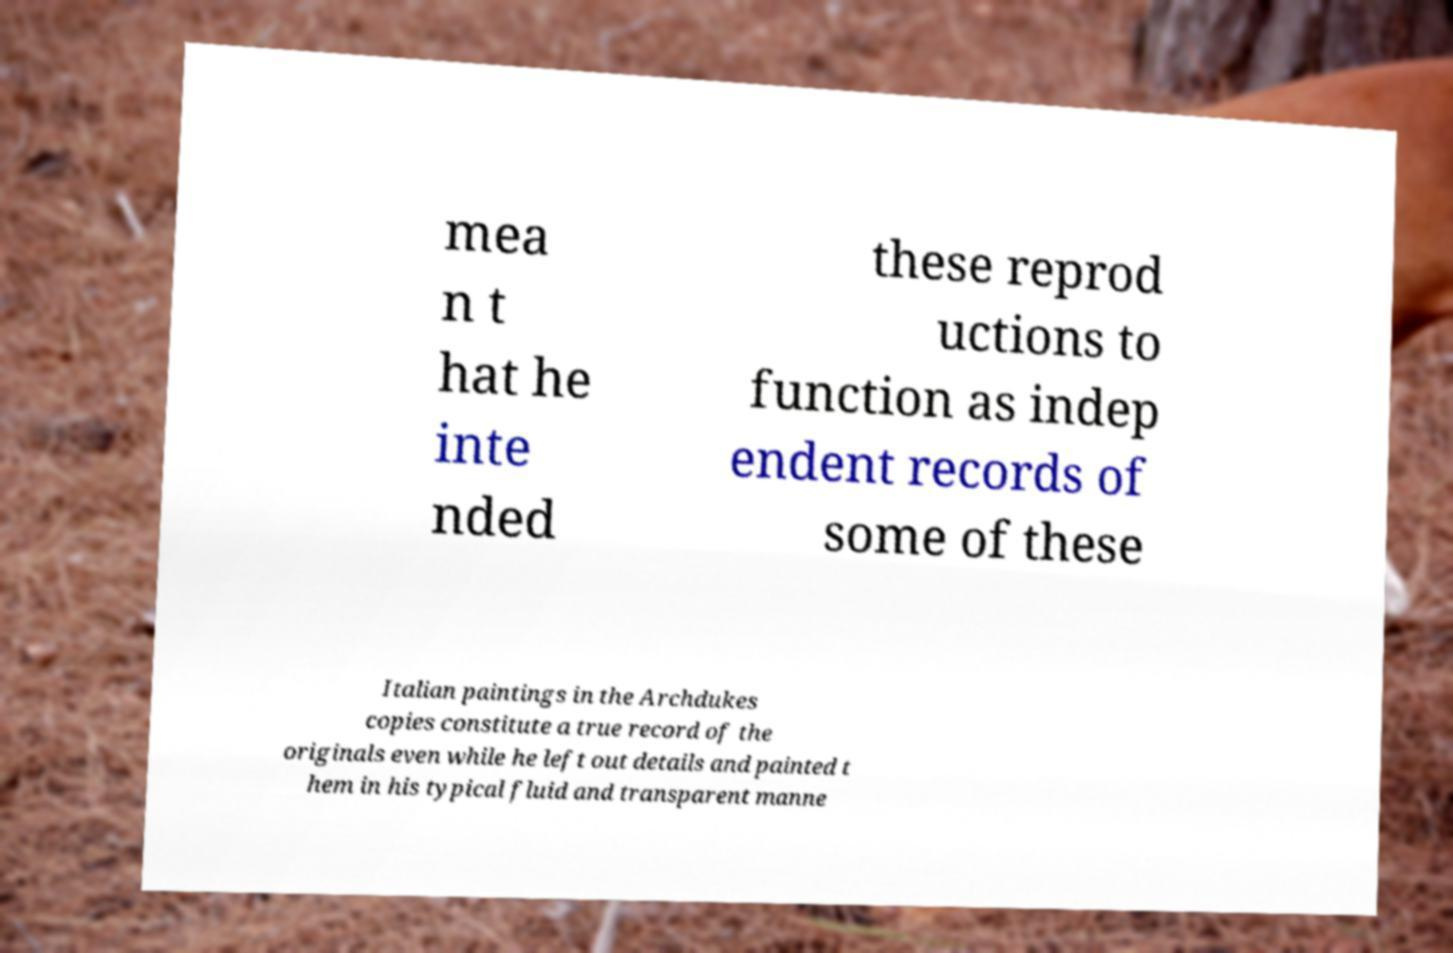Please identify and transcribe the text found in this image. mea n t hat he inte nded these reprod uctions to function as indep endent records of some of these Italian paintings in the Archdukes copies constitute a true record of the originals even while he left out details and painted t hem in his typical fluid and transparent manne 